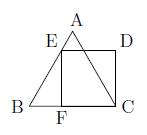Let $ABC$ be an equilateral triangle and $CDEF$ a square such that $E$ lies on segment $AB$ and $F$ on segment $BC$. If the perimeter of the square is equal to $4$, what is the area of triangle $ABC$? To find the area of triangle $ABC$, we note that if the perimeter of the square $CDEF$ is 4, each side of the square is 1 unit. We can use this side length to find the lengths of $AB$ and $BC$. Since $E$ and $F$ lie on $AB$ and $BC$ respectively, each side of triangle $ABC$ becomes the hypotenuse of right triangles formed with the square's side. The length of each side of triangle $ABC$ can be calculated using the Pythagorean theorem, and then the area of the equilateral triangle can be computed using the formula for the area of an equilateral triangle, $\frac{\sqrt{3}}{4} s^2$, where $s$ is the side length. By doing so, we find that the area of $ABC$ is approximately $\sqrt{3}$ square units. 